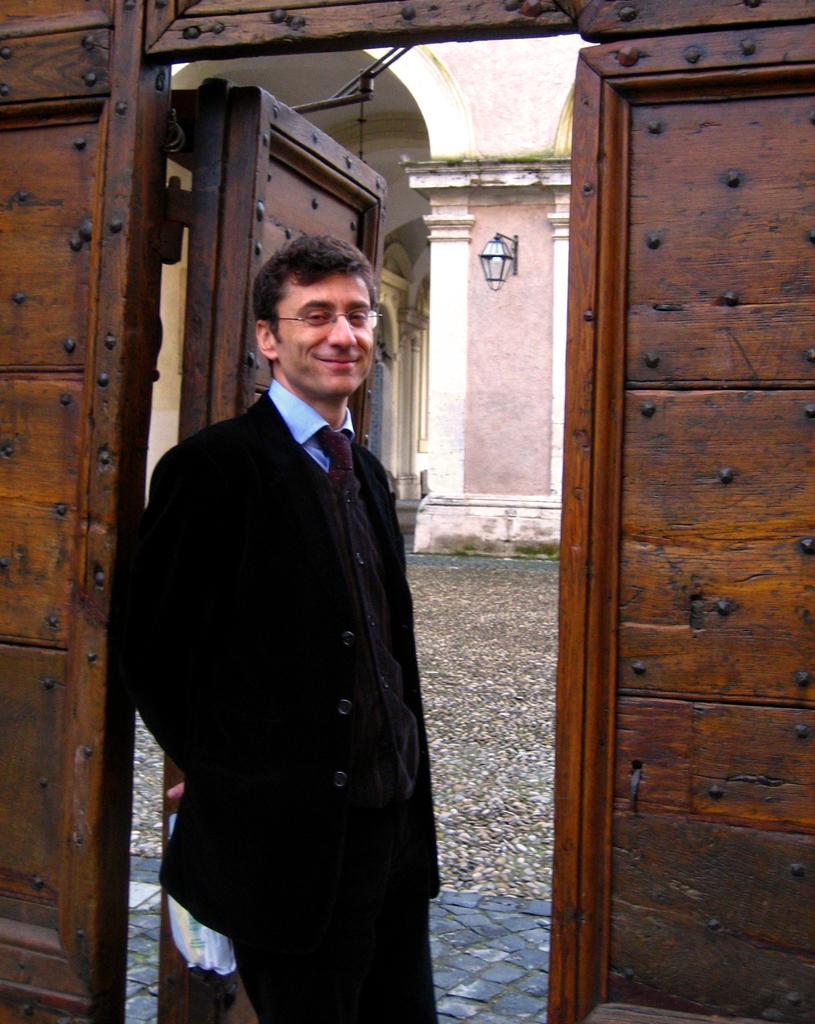Can you describe this image briefly? In the center of the image we can see one person standing and he is holding some object and he is smiling. And there is a wooden wall and door. In the background we can see one building, one lamp and a few other objects. 